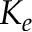Convert formula to latex. <formula><loc_0><loc_0><loc_500><loc_500>K _ { e }</formula> 